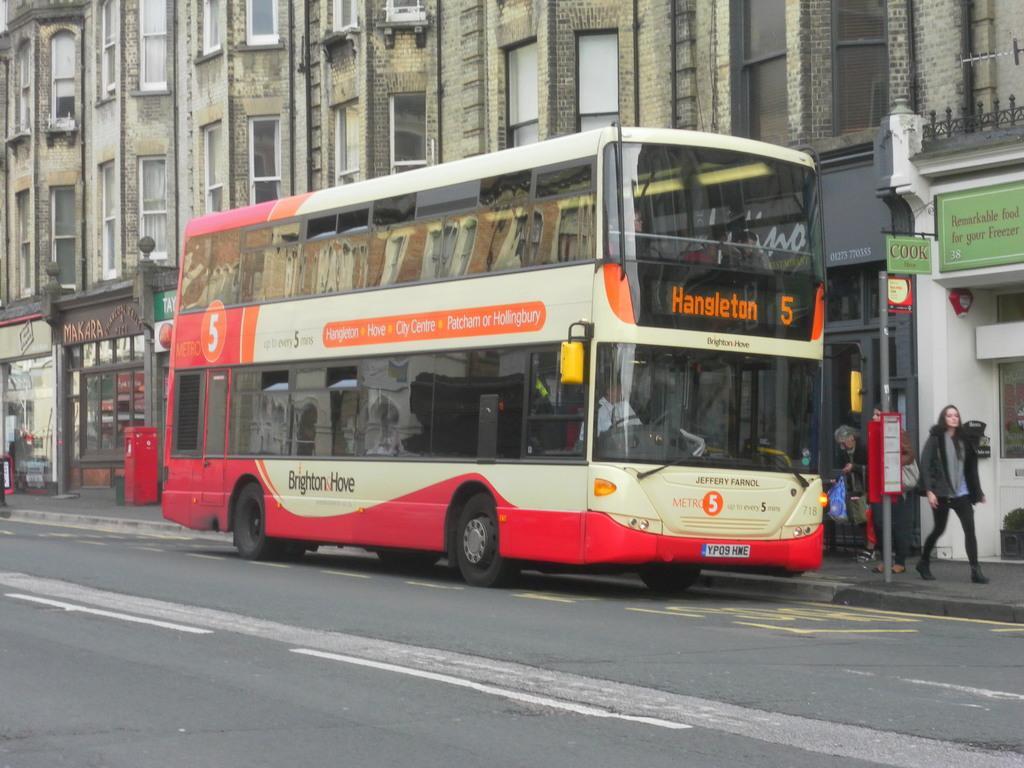Could you give a brief overview of what you see in this image? In this we can see a bus on road, few people on the pavement a pole with board and there are few buildings with boards and a red color box in the background. 